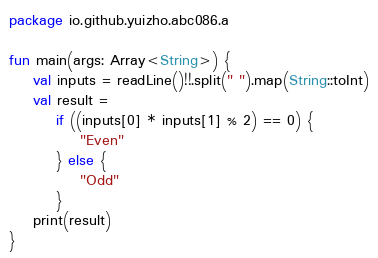Convert code to text. <code><loc_0><loc_0><loc_500><loc_500><_Kotlin_>package io.github.yuizho.abc086.a

fun main(args: Array<String>) {
    val inputs = readLine()!!.split(" ").map(String::toInt)
    val result =
        if ((inputs[0] * inputs[1] % 2) == 0) {
            "Even"
        } else {
            "Odd"
        }
    print(result)
}</code> 